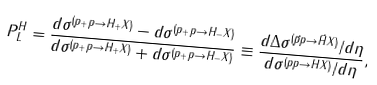<formula> <loc_0><loc_0><loc_500><loc_500>P _ { L } ^ { H } = \frac { d \sigma ^ { ( p _ { + } p \to H _ { + } X ) } - d \sigma ^ { ( p _ { + } p \to H _ { - } X ) } } { d \sigma ^ { ( p _ { + } p \to H _ { + } X ) } + d \sigma ^ { ( p _ { + } p \to H _ { - } X ) } } \equiv \frac { d \Delta \sigma ^ { ( \vec { p } p \to \vec { H } X ) } / d \eta } { d \sigma ^ { ( p p \to H X ) } / d \eta } ,</formula> 